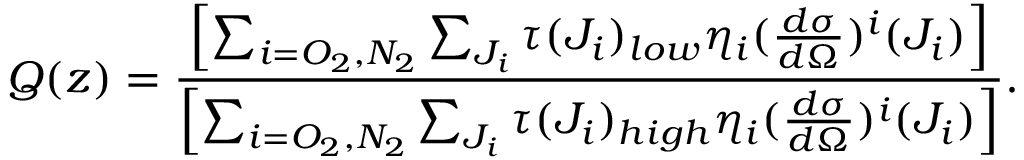<formula> <loc_0><loc_0><loc_500><loc_500>Q ( z ) = \frac { \left [ \sum _ { i = O _ { 2 } , N _ { 2 } } \sum _ { J _ { i } } \tau ( J _ { i } ) _ { l o w } \eta _ { i } ( \frac { d \sigma } { d \Omega } ) ^ { i } ( J _ { i } ) \right ] } { \left [ \sum _ { i = O _ { 2 } , N _ { 2 } } \sum _ { J _ { i } } \tau ( J _ { i } ) _ { h i g h } \eta _ { i } ( \frac { d \sigma } { d \Omega } ) ^ { i } ( J _ { i } ) \right ] } .</formula> 